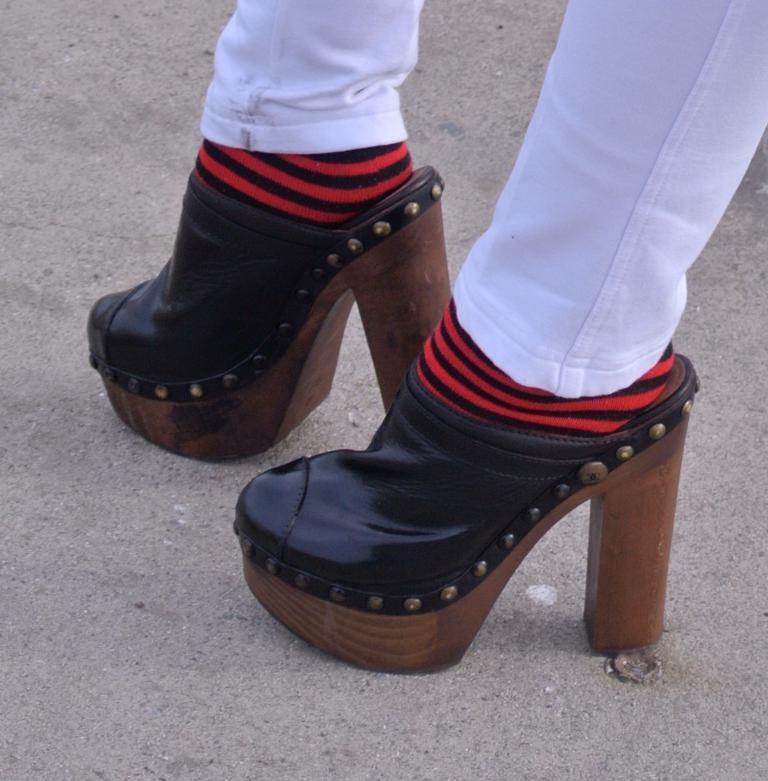Can you describe this image briefly? In this picture there are two legs in the center of the image. 